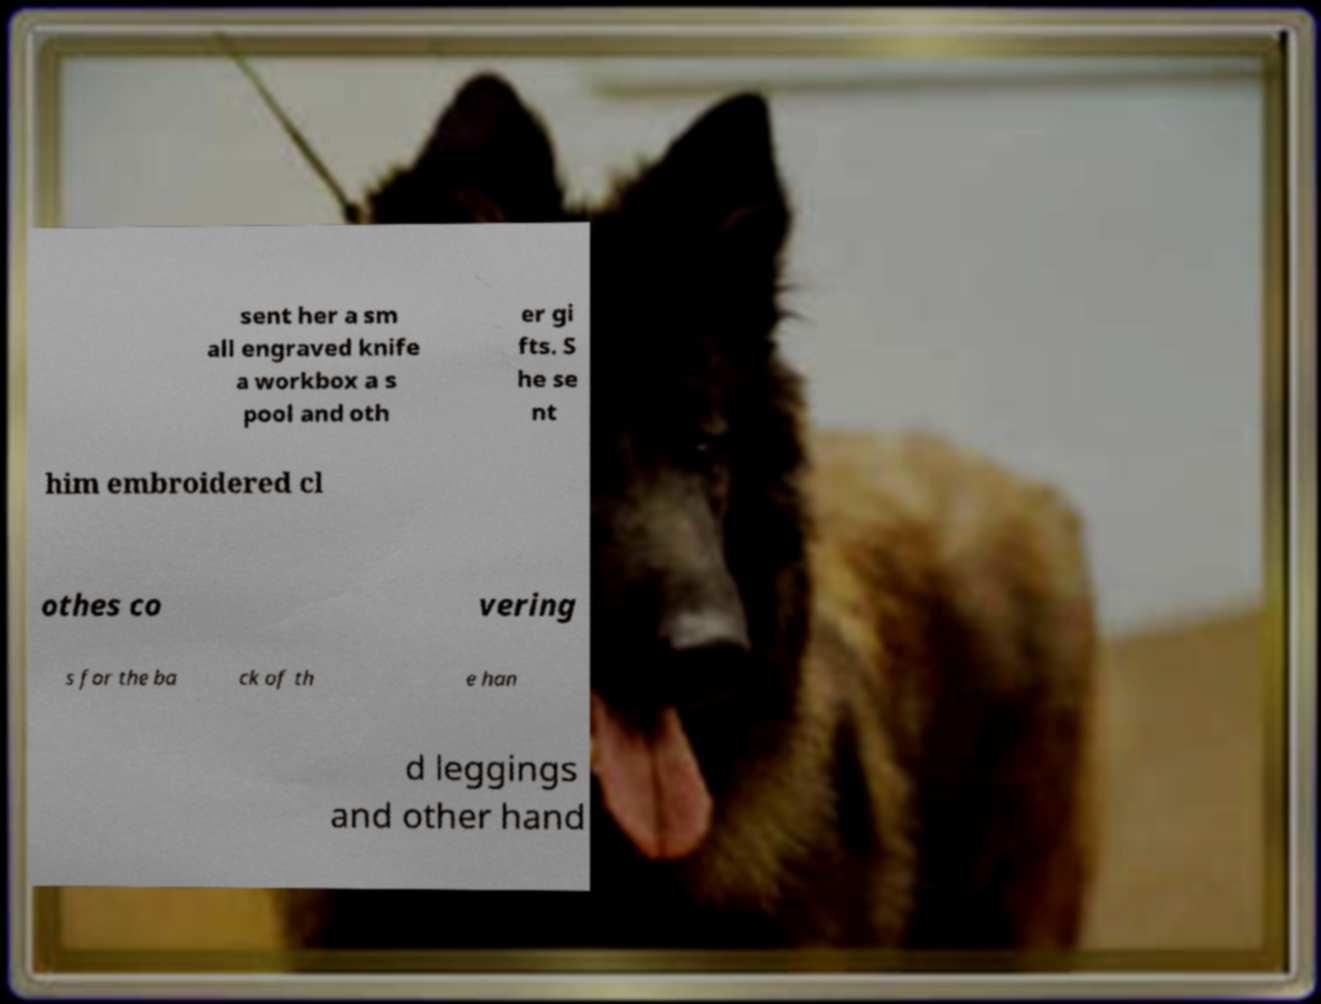There's text embedded in this image that I need extracted. Can you transcribe it verbatim? sent her a sm all engraved knife a workbox a s pool and oth er gi fts. S he se nt him embroidered cl othes co vering s for the ba ck of th e han d leggings and other hand 